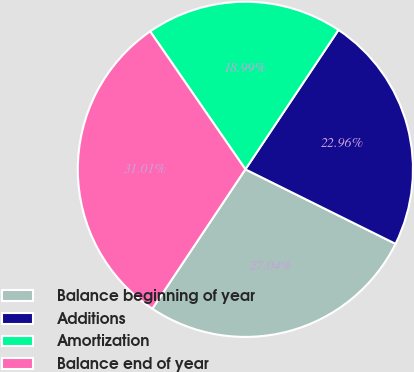Convert chart. <chart><loc_0><loc_0><loc_500><loc_500><pie_chart><fcel>Balance beginning of year<fcel>Additions<fcel>Amortization<fcel>Balance end of year<nl><fcel>27.04%<fcel>22.96%<fcel>18.99%<fcel>31.01%<nl></chart> 